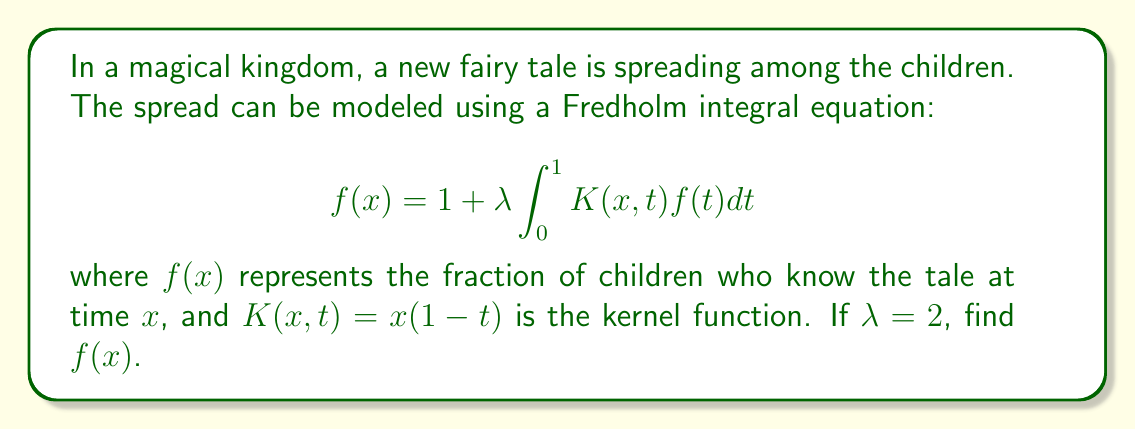Can you solve this math problem? To solve this Fredholm integral equation, we'll follow these steps:

1) First, we assume that $f(x)$ is a polynomial of degree 2:
   $$f(x) = a + bx + cx^2$$

2) Substitute this into the integral equation:
   $$a + bx + cx^2 = 1 + 2 \int_0^1 x(1-t)(a + bt + ct^2)dt$$

3) Evaluate the integral:
   $$\begin{align}
   a + bx + cx^2 &= 1 + 2x \int_0^1 (a + bt + ct^2 - at - bt^2 - ct^3)dt \\
   &= 1 + 2x \left[at + \frac{bt^2}{2} + \frac{ct^3}{3} - \frac{at^2}{2} - \frac{bt^3}{3} - \frac{ct^4}{4}\right]_0^1 \\
   &= 1 + 2x \left(a + \frac{b}{2} + \frac{c}{3} - \frac{a}{2} - \frac{b}{3} - \frac{c}{4}\right) \\
   &= 1 + 2x \left(\frac{a}{2} + \frac{b}{6} + \frac{c}{12}\right)
   \end{align}$$

4) Equate coefficients:
   Constant term: $a = 1$
   $x$ term: $b = a + \frac{b}{3} + \frac{c}{6}$
   $x^2$ term: $c = 0$

5) From these equations:
   $a = 1$
   $c = 0$
   $b = 1 + \frac{b}{3}$

6) Solve for $b$:
   $$\begin{align}
   b &= 1 + \frac{b}{3} \\
   \frac{2b}{3} &= 1 \\
   b &= \frac{3}{2}
   \end{align}$$

7) Therefore, the solution is:
   $$f(x) = 1 + \frac{3}{2}x$$
Answer: $f(x) = 1 + \frac{3}{2}x$ 